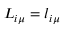Convert formula to latex. <formula><loc_0><loc_0><loc_500><loc_500>L _ { i \mu } = l _ { i \mu }</formula> 